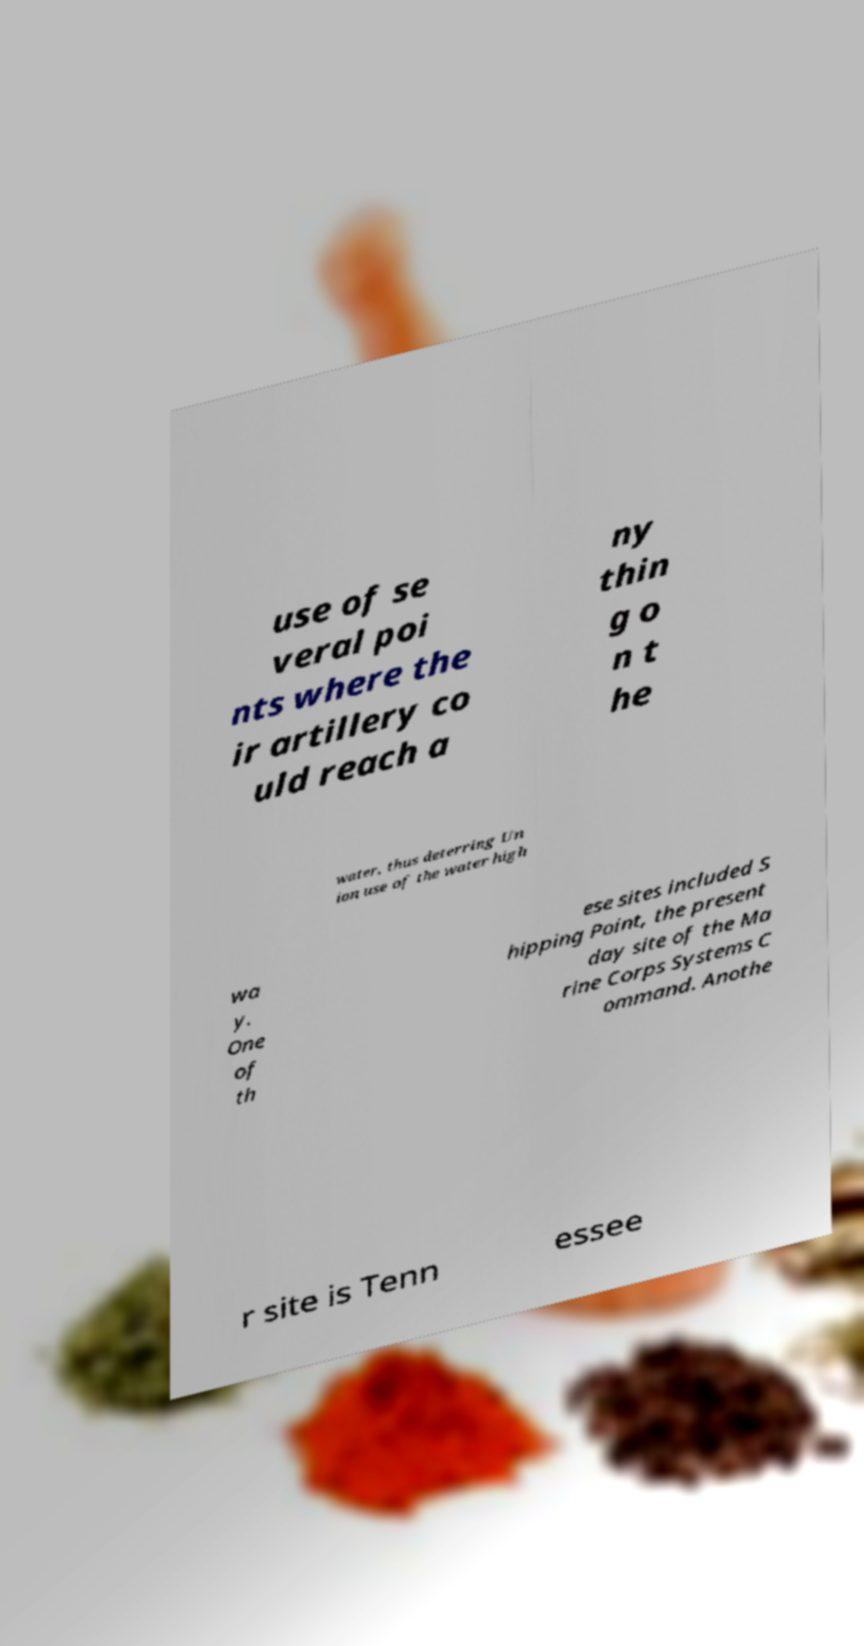Could you assist in decoding the text presented in this image and type it out clearly? use of se veral poi nts where the ir artillery co uld reach a ny thin g o n t he water, thus deterring Un ion use of the water high wa y. One of th ese sites included S hipping Point, the present day site of the Ma rine Corps Systems C ommand. Anothe r site is Tenn essee 